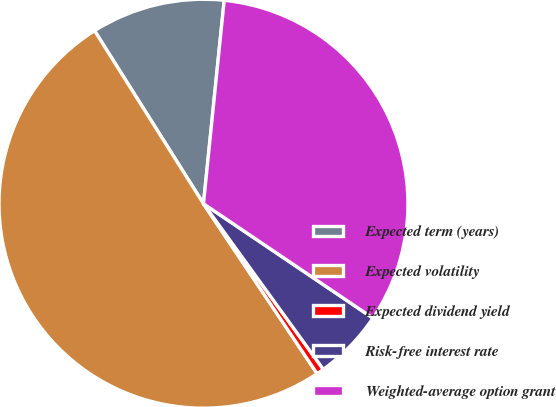Convert chart. <chart><loc_0><loc_0><loc_500><loc_500><pie_chart><fcel>Expected term (years)<fcel>Expected volatility<fcel>Expected dividend yield<fcel>Risk-free interest rate<fcel>Weighted-average option grant<nl><fcel>10.56%<fcel>50.43%<fcel>0.59%<fcel>5.58%<fcel>32.83%<nl></chart> 